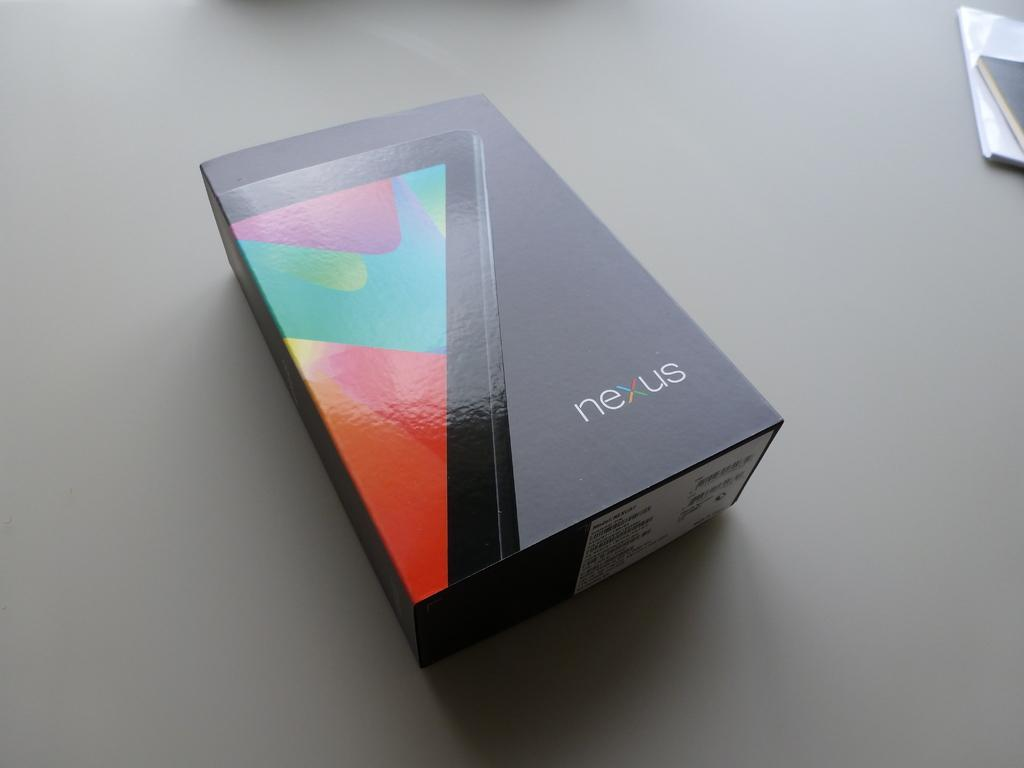<image>
Offer a succinct explanation of the picture presented. A colorful image is on one side of a black nexus box. 